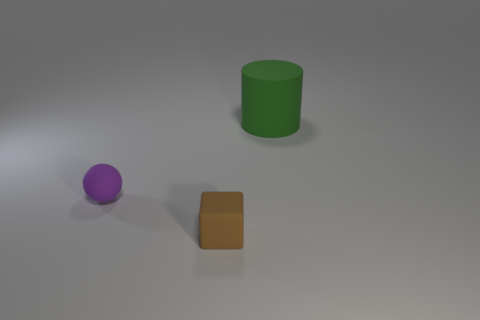Add 1 small cyan cubes. How many objects exist? 4 Subtract all cylinders. How many objects are left? 2 Subtract 1 green cylinders. How many objects are left? 2 Subtract all small brown objects. Subtract all small rubber blocks. How many objects are left? 1 Add 2 tiny brown cubes. How many tiny brown cubes are left? 3 Add 1 yellow balls. How many yellow balls exist? 1 